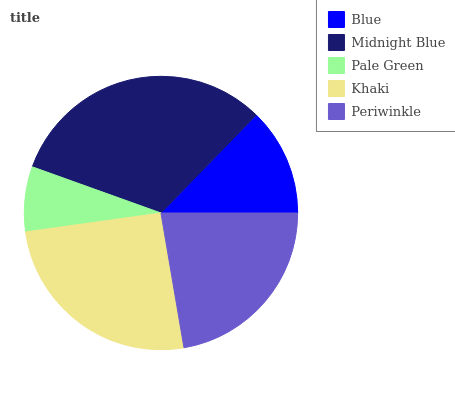Is Pale Green the minimum?
Answer yes or no. Yes. Is Midnight Blue the maximum?
Answer yes or no. Yes. Is Midnight Blue the minimum?
Answer yes or no. No. Is Pale Green the maximum?
Answer yes or no. No. Is Midnight Blue greater than Pale Green?
Answer yes or no. Yes. Is Pale Green less than Midnight Blue?
Answer yes or no. Yes. Is Pale Green greater than Midnight Blue?
Answer yes or no. No. Is Midnight Blue less than Pale Green?
Answer yes or no. No. Is Periwinkle the high median?
Answer yes or no. Yes. Is Periwinkle the low median?
Answer yes or no. Yes. Is Midnight Blue the high median?
Answer yes or no. No. Is Khaki the low median?
Answer yes or no. No. 